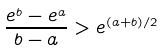<formula> <loc_0><loc_0><loc_500><loc_500>\frac { e ^ { b } - e ^ { a } } { b - a } > e ^ { ( a + b ) / 2 }</formula> 